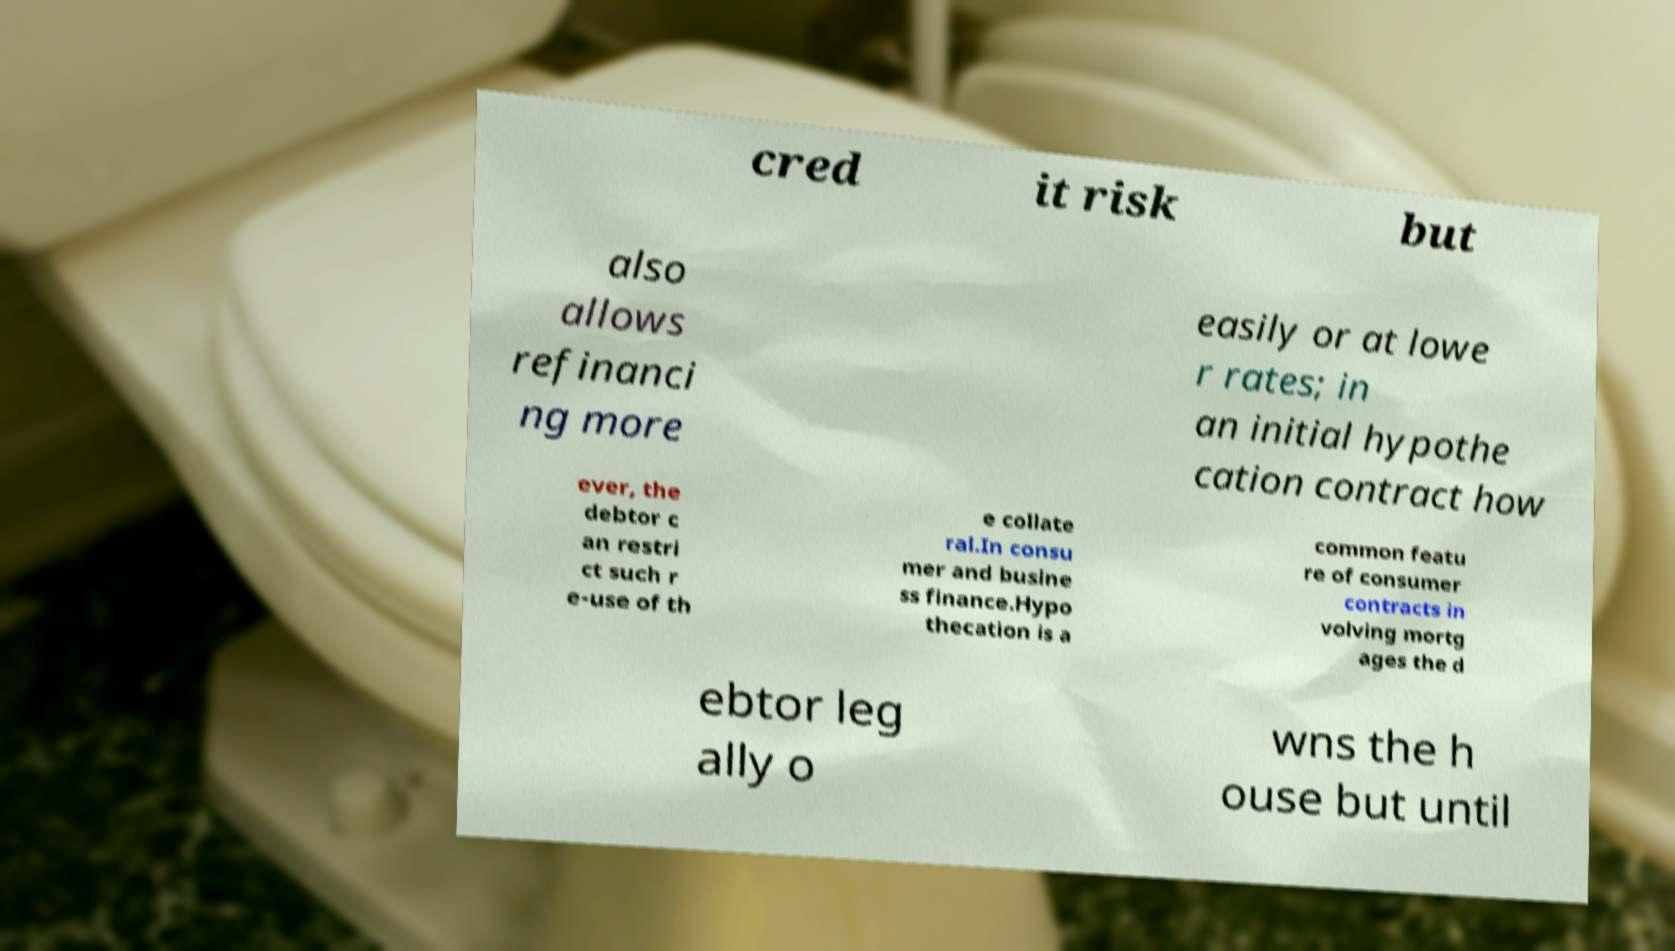There's text embedded in this image that I need extracted. Can you transcribe it verbatim? cred it risk but also allows refinanci ng more easily or at lowe r rates; in an initial hypothe cation contract how ever, the debtor c an restri ct such r e-use of th e collate ral.In consu mer and busine ss finance.Hypo thecation is a common featu re of consumer contracts in volving mortg ages the d ebtor leg ally o wns the h ouse but until 